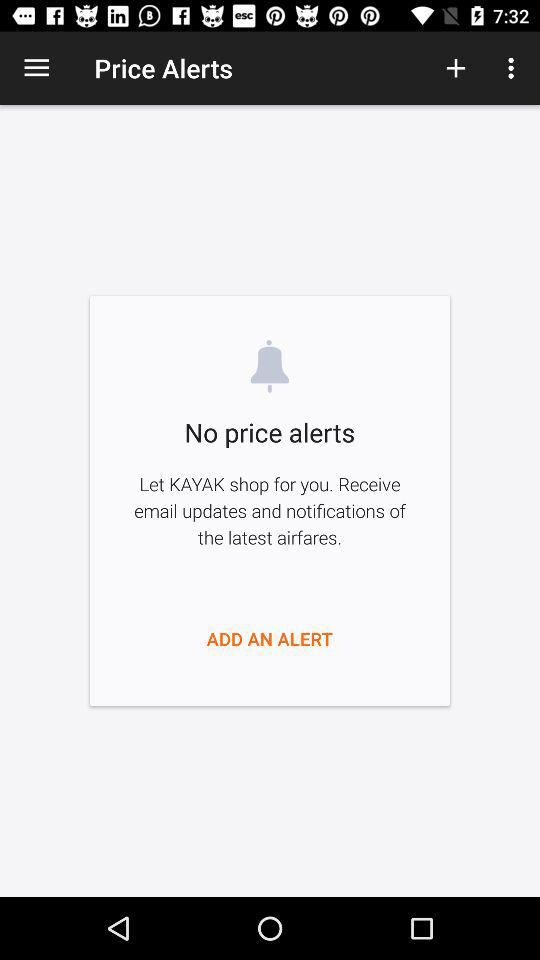Is there any price alert? There is no price alert. 